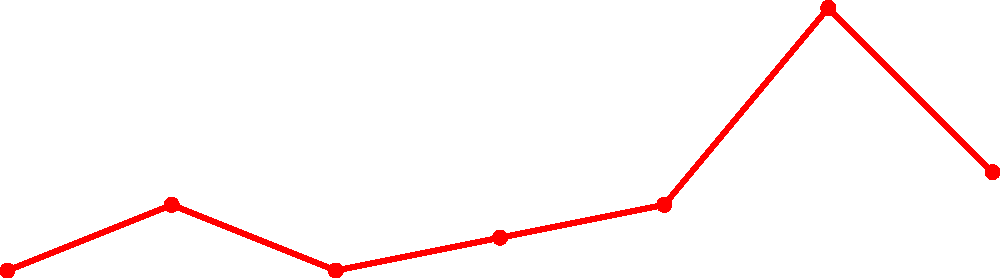Looking at Brøndby IF's league positions from 1990 to 2020, in which year did the team experience its worst finish according to the graph? To determine Brøndby IF's worst finish between 1990 and 2020, we need to follow these steps:

1. Analyze the graph, which shows Brøndby IF's league positions over the years.
2. Remember that in football leagues, a higher number indicates a lower finish (e.g., 1st is better than 9th).
3. Examine each data point on the graph:
   - 1990: 1st place
   - 1995: 3rd place
   - 2000: 1st place
   - 2005: 2nd place
   - 2010: 3rd place
   - 2015: 9th place
   - 2020: 4th place
4. Identify the highest number among these positions, which represents the worst finish.

The highest number (worst finish) is 9th place, which occurred in 2015.
Answer: 2015 